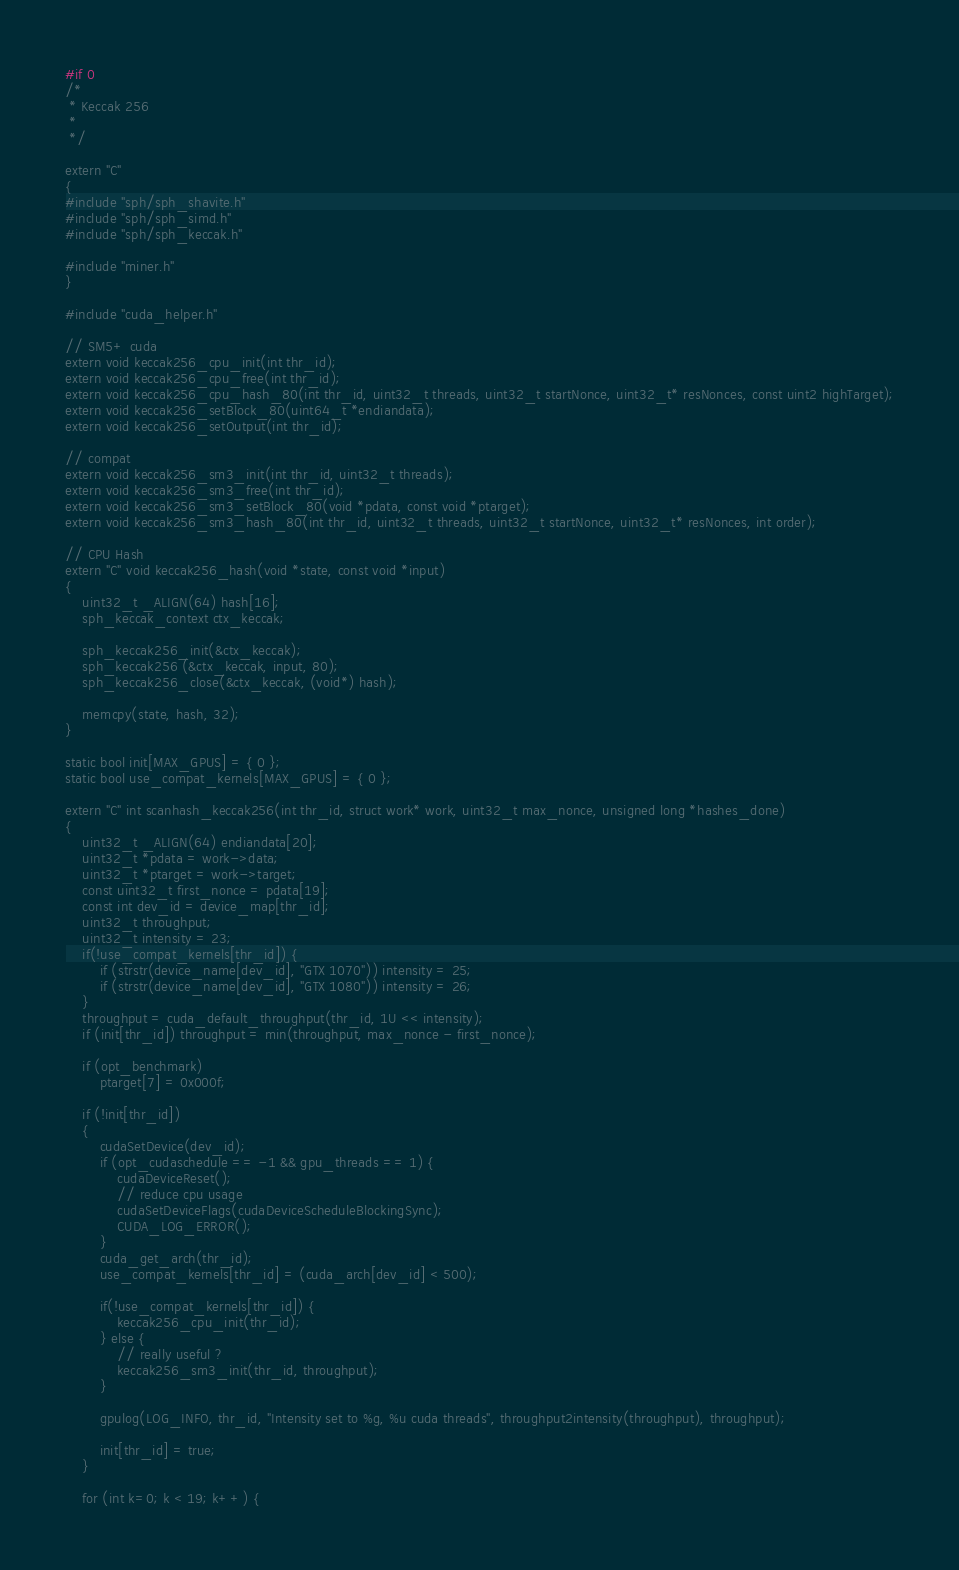Convert code to text. <code><loc_0><loc_0><loc_500><loc_500><_Cuda_>#if 0
/*
 * Keccak 256
 *
 */

extern "C"
{
#include "sph/sph_shavite.h"
#include "sph/sph_simd.h"
#include "sph/sph_keccak.h"

#include "miner.h"
}

#include "cuda_helper.h"

// SM5+ cuda
extern void keccak256_cpu_init(int thr_id);
extern void keccak256_cpu_free(int thr_id);
extern void keccak256_cpu_hash_80(int thr_id, uint32_t threads, uint32_t startNonce, uint32_t* resNonces, const uint2 highTarget);
extern void keccak256_setBlock_80(uint64_t *endiandata);
extern void keccak256_setOutput(int thr_id);

// compat
extern void keccak256_sm3_init(int thr_id, uint32_t threads);
extern void keccak256_sm3_free(int thr_id);
extern void keccak256_sm3_setBlock_80(void *pdata, const void *ptarget);
extern void keccak256_sm3_hash_80(int thr_id, uint32_t threads, uint32_t startNonce, uint32_t* resNonces, int order);

// CPU Hash
extern "C" void keccak256_hash(void *state, const void *input)
{
	uint32_t _ALIGN(64) hash[16];
	sph_keccak_context ctx_keccak;

	sph_keccak256_init(&ctx_keccak);
	sph_keccak256 (&ctx_keccak, input, 80);
	sph_keccak256_close(&ctx_keccak, (void*) hash);

	memcpy(state, hash, 32);
}

static bool init[MAX_GPUS] = { 0 };
static bool use_compat_kernels[MAX_GPUS] = { 0 };

extern "C" int scanhash_keccak256(int thr_id, struct work* work, uint32_t max_nonce, unsigned long *hashes_done)
{
	uint32_t _ALIGN(64) endiandata[20];
	uint32_t *pdata = work->data;
	uint32_t *ptarget = work->target;
	const uint32_t first_nonce = pdata[19];
	const int dev_id = device_map[thr_id];
	uint32_t throughput;
	uint32_t intensity = 23;
	if(!use_compat_kernels[thr_id]) {
		if (strstr(device_name[dev_id], "GTX 1070")) intensity = 25;
		if (strstr(device_name[dev_id], "GTX 1080")) intensity = 26;
	}
	throughput = cuda_default_throughput(thr_id, 1U << intensity);
	if (init[thr_id]) throughput = min(throughput, max_nonce - first_nonce);

	if (opt_benchmark)
		ptarget[7] = 0x000f;

	if (!init[thr_id])
	{
		cudaSetDevice(dev_id);
		if (opt_cudaschedule == -1 && gpu_threads == 1) {
			cudaDeviceReset();
			// reduce cpu usage
			cudaSetDeviceFlags(cudaDeviceScheduleBlockingSync);
			CUDA_LOG_ERROR();
		}
		cuda_get_arch(thr_id);
		use_compat_kernels[thr_id] = (cuda_arch[dev_id] < 500);

		if(!use_compat_kernels[thr_id]) {
			keccak256_cpu_init(thr_id);
		} else {
			// really useful ?
			keccak256_sm3_init(thr_id, throughput);
		}

		gpulog(LOG_INFO, thr_id, "Intensity set to %g, %u cuda threads", throughput2intensity(throughput), throughput);

		init[thr_id] = true;
	}

	for (int k=0; k < 19; k++) {</code> 